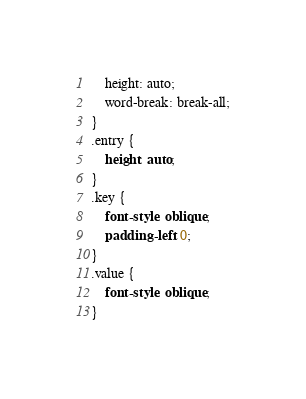Convert code to text. <code><loc_0><loc_0><loc_500><loc_500><_CSS_>    height: auto;
    word-break: break-all;
}
.entry {
    height: auto;
}
.key {
    font-style: oblique;
    padding-left: 0;
}
.value {
    font-style: oblique;
}</code> 